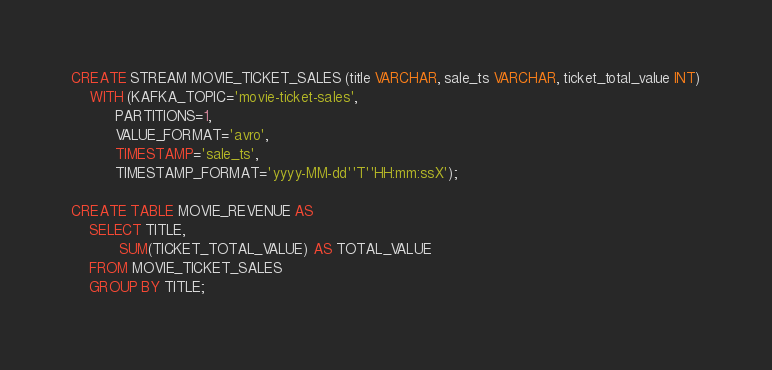<code> <loc_0><loc_0><loc_500><loc_500><_SQL_>CREATE STREAM MOVIE_TICKET_SALES (title VARCHAR, sale_ts VARCHAR, ticket_total_value INT)
    WITH (KAFKA_TOPIC='movie-ticket-sales',
          PARTITIONS=1,
          VALUE_FORMAT='avro',
          TIMESTAMP='sale_ts',
          TIMESTAMP_FORMAT='yyyy-MM-dd''T''HH:mm:ssX');

CREATE TABLE MOVIE_REVENUE AS
    SELECT TITLE,
           SUM(TICKET_TOTAL_VALUE) AS TOTAL_VALUE
    FROM MOVIE_TICKET_SALES
    GROUP BY TITLE;
</code> 